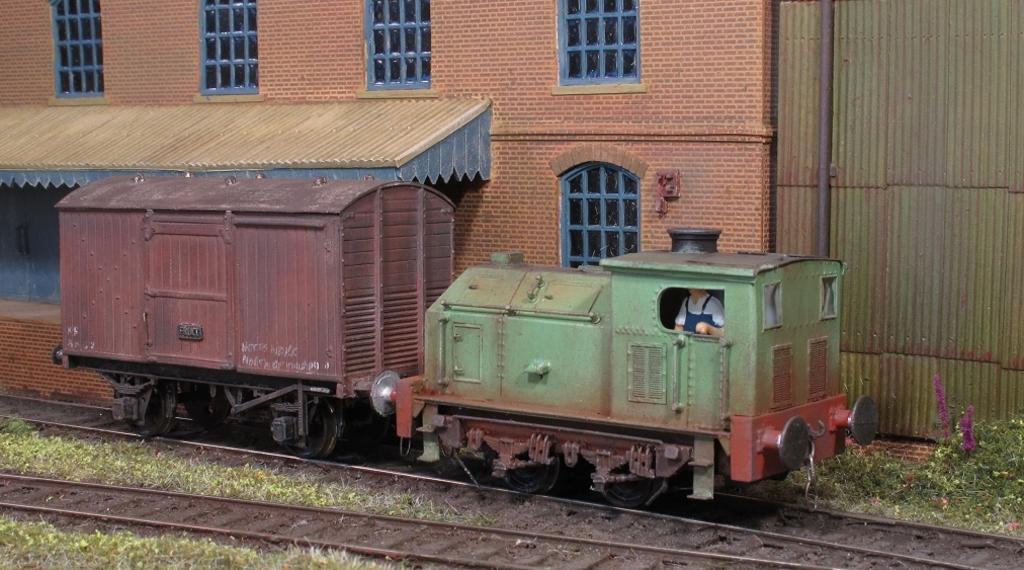Can you describe this image briefly? Here I can see a train engine on the railway track. At the bottom of the image I can see the grass. In the background there is a building. On the right side, I can see a shed and some plants. Here I can see a person inside the engine. 